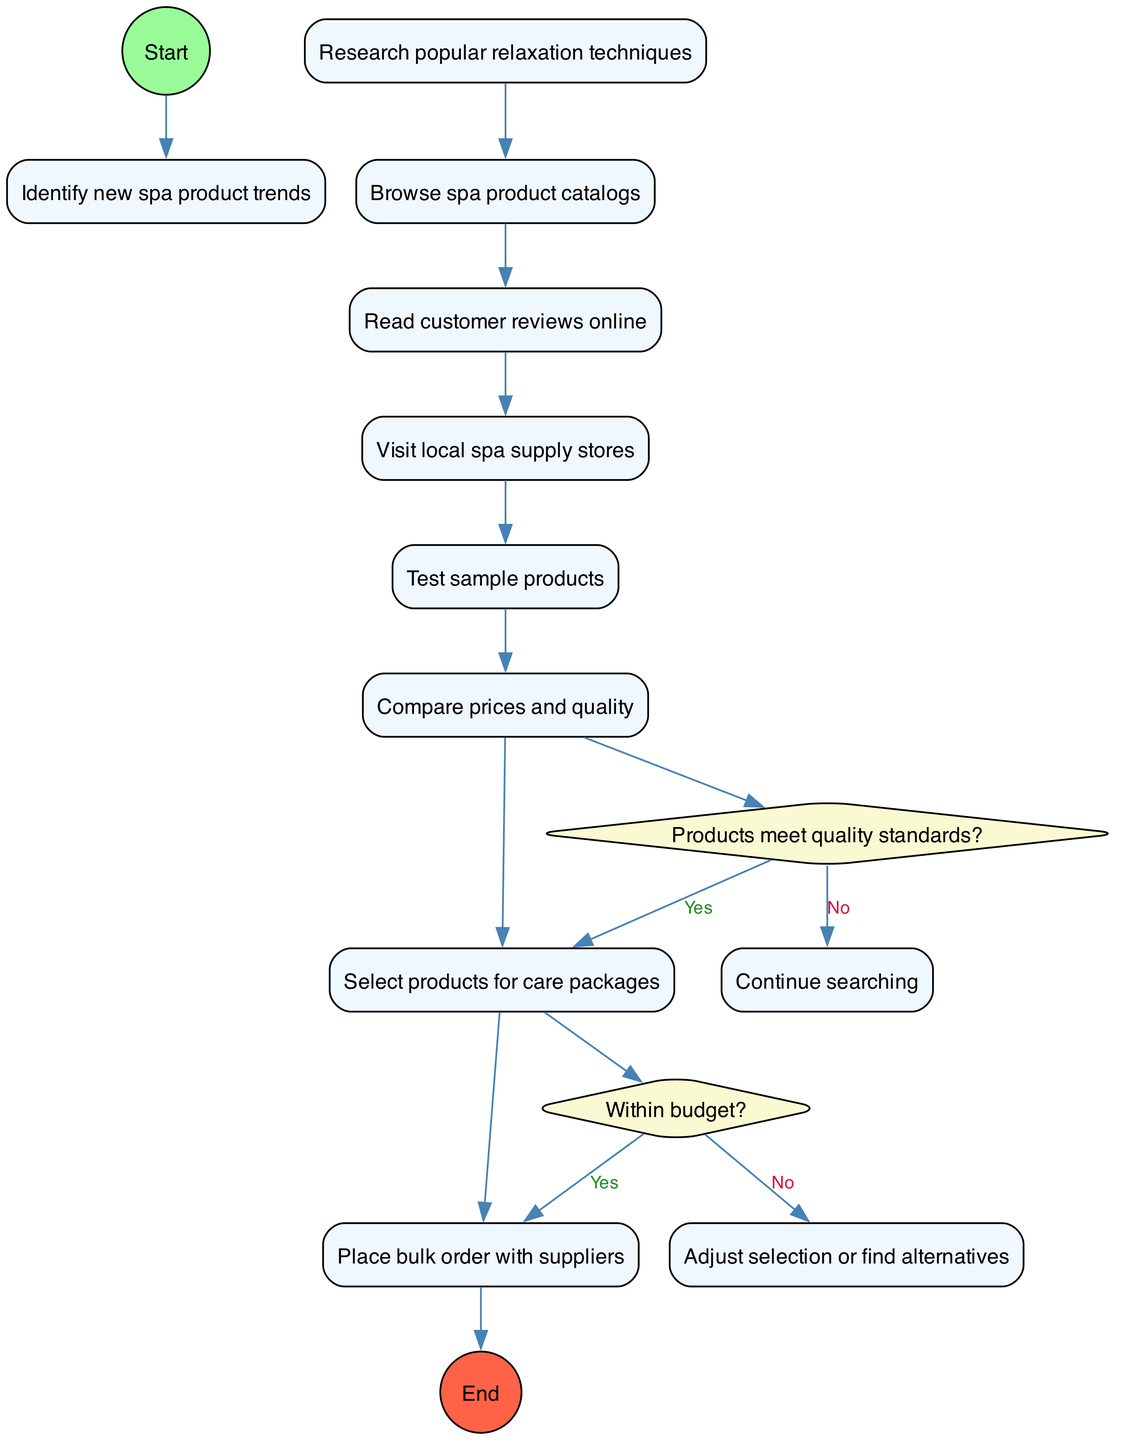What is the starting point of the activity diagram? The starting point is clearly indicated as "Identify new spa product trends" following the 'Start' node. This is the first activity after initiating the diagram.
Answer: Identify new spa product trends How many activities are listed in the diagram? To find the number of activities, I count the distinct activities listed under the "activities" section. There are eight activities presented.
Answer: 8 What are the two decision points in the diagram? The decision points are labeled with questions. The first decision point asks "Products meet quality standards?" and the second asks "Within budget?". These are identified as diamond shapes in the structure.
Answer: Products meet quality standards?; Within budget? What happens if products do not meet quality standards? Following the decision point related to quality standards, if the answer is "No," the flow indicates to "Continue searching," meaning the process returns to finding suitable products.
Answer: Continue searching What is the final action in this activity diagram? The final action is represented at the end node, which shows "Prepare care packages for shipping." This occurs after placing the bulk order with suppliers.
Answer: Prepare care packages for shipping If a selected product is outside budget, what is the next step? If the selected product exceeds the budget, the flow directs to "Adjust selection or find alternatives," indicating a need for reevaluation before proceeding.
Answer: Adjust selection or find alternatives What is the last activity before placing a bulk order with suppliers? The last activity listed before placing an order with suppliers is "Compare prices and quality." This indicates that assessment is required before bulk purchasing.
Answer: Compare prices and quality Which two activities are performed before the first decision point? The first two activities listed prior to the first decision point (regarding quality standards) are "Research popular relaxation techniques" and "Browse spa product catalogs." This shows the initial steps in sourcing products.
Answer: Research popular relaxation techniques; Browse spa product catalogs 